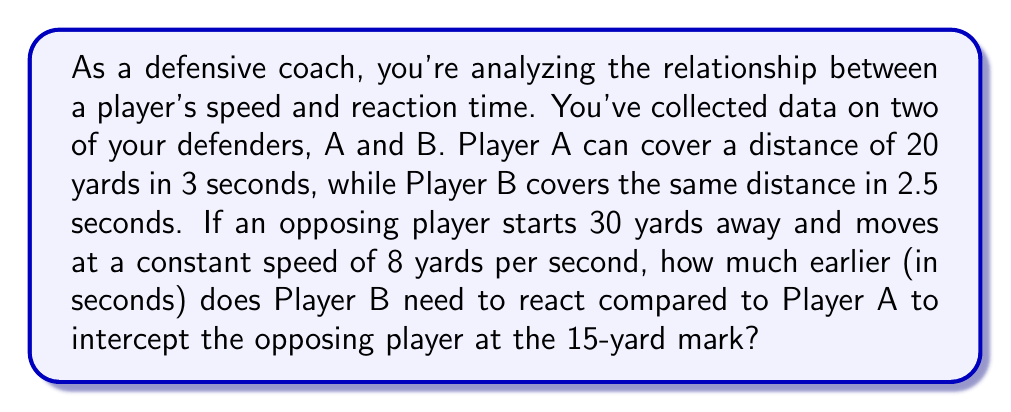Could you help me with this problem? Let's approach this step-by-step:

1) First, calculate the speeds of Players A and B:
   Player A: $v_A = \frac{20 \text{ yards}}{3 \text{ seconds}} = \frac{20}{3} \text{ yards/second}$
   Player B: $v_B = \frac{20 \text{ yards}}{2.5 \text{ seconds}} = 8 \text{ yards/second}$

2) The opposing player needs to cover 15 yards (30 - 15 = 15). At 8 yards/second, this takes:
   $t_{opposing} = \frac{15 \text{ yards}}{8 \text{ yards/second}} = 1.875 \text{ seconds}$

3) Now, we need to find how long it takes each defender to cover 15 yards:
   Player A: $t_A = \frac{15 \text{ yards}}{\frac{20}{3} \text{ yards/second}} = \frac{45}{20} = 2.25 \text{ seconds}$
   Player B: $t_B = \frac{15 \text{ yards}}{8 \text{ yards/second}} = 1.875 \text{ seconds}$

4) The difference in reaction time is:
   $\Delta t = t_A - t_B = 2.25 - 1.875 = 0.375 \text{ seconds}$

Therefore, Player B needs to react 0.375 seconds earlier than Player A to intercept the opposing player at the 15-yard mark.
Answer: Player B needs to react 0.375 seconds earlier than Player A. 